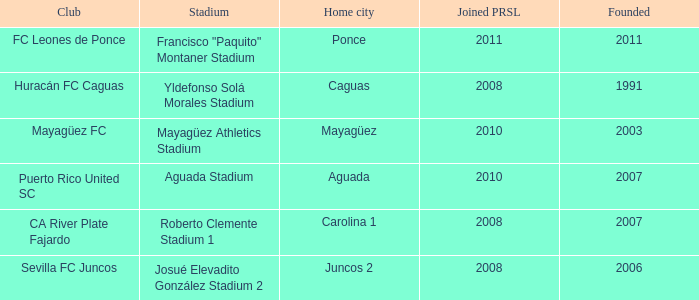What is the earliest founded when the home city is mayagüez? 2003.0. Would you mind parsing the complete table? {'header': ['Club', 'Stadium', 'Home city', 'Joined PRSL', 'Founded'], 'rows': [['FC Leones de Ponce', 'Francisco "Paquito" Montaner Stadium', 'Ponce', '2011', '2011'], ['Huracán FC Caguas', 'Yldefonso Solá Morales Stadium', 'Caguas', '2008', '1991'], ['Mayagüez FC', 'Mayagüez Athletics Stadium', 'Mayagüez', '2010', '2003'], ['Puerto Rico United SC', 'Aguada Stadium', 'Aguada', '2010', '2007'], ['CA River Plate Fajardo', 'Roberto Clemente Stadium 1', 'Carolina 1', '2008', '2007'], ['Sevilla FC Juncos', 'Josué Elevadito González Stadium 2', 'Juncos 2', '2008', '2006']]} 